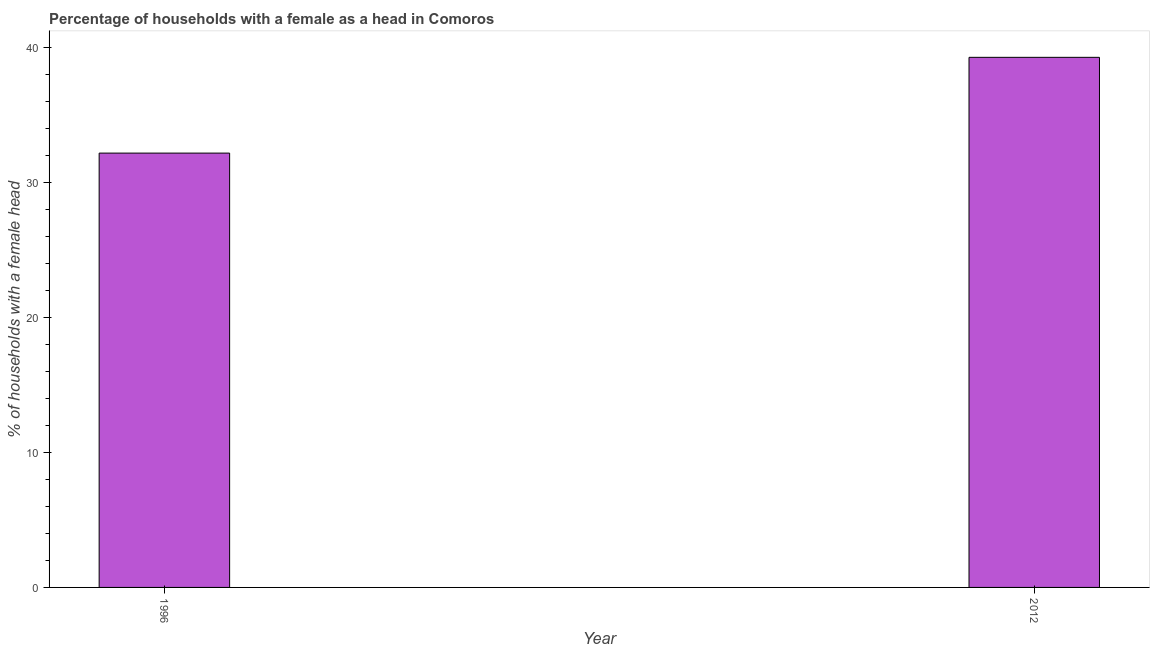Does the graph contain grids?
Your answer should be compact. No. What is the title of the graph?
Provide a succinct answer. Percentage of households with a female as a head in Comoros. What is the label or title of the Y-axis?
Make the answer very short. % of households with a female head. What is the number of female supervised households in 2012?
Give a very brief answer. 39.3. Across all years, what is the maximum number of female supervised households?
Provide a succinct answer. 39.3. Across all years, what is the minimum number of female supervised households?
Ensure brevity in your answer.  32.2. In which year was the number of female supervised households minimum?
Give a very brief answer. 1996. What is the sum of the number of female supervised households?
Make the answer very short. 71.5. What is the average number of female supervised households per year?
Provide a succinct answer. 35.75. What is the median number of female supervised households?
Ensure brevity in your answer.  35.75. In how many years, is the number of female supervised households greater than 22 %?
Keep it short and to the point. 2. What is the ratio of the number of female supervised households in 1996 to that in 2012?
Your answer should be very brief. 0.82. Is the number of female supervised households in 1996 less than that in 2012?
Keep it short and to the point. Yes. In how many years, is the number of female supervised households greater than the average number of female supervised households taken over all years?
Offer a terse response. 1. How many bars are there?
Keep it short and to the point. 2. How many years are there in the graph?
Your answer should be very brief. 2. Are the values on the major ticks of Y-axis written in scientific E-notation?
Provide a succinct answer. No. What is the % of households with a female head of 1996?
Provide a succinct answer. 32.2. What is the % of households with a female head in 2012?
Keep it short and to the point. 39.3. What is the difference between the % of households with a female head in 1996 and 2012?
Offer a terse response. -7.1. What is the ratio of the % of households with a female head in 1996 to that in 2012?
Your answer should be very brief. 0.82. 